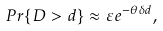<formula> <loc_0><loc_0><loc_500><loc_500>P r \{ D > d \} \approx \varepsilon e ^ { - \theta \delta d } ,</formula> 